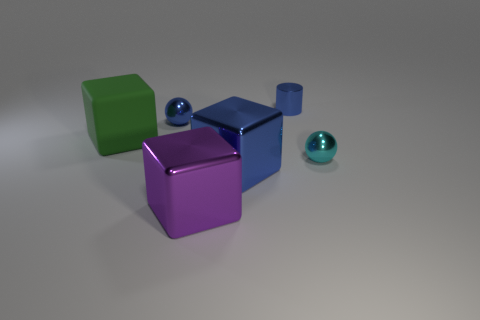There is a big cube behind the sphere in front of the big green cube; what is it made of?
Give a very brief answer. Rubber. Is there a large green thing of the same shape as the cyan shiny thing?
Make the answer very short. No. How many other things are there of the same shape as the big purple metal thing?
Give a very brief answer. 2. There is a metal thing that is in front of the small blue metallic ball and to the left of the big blue shiny object; what shape is it?
Offer a very short reply. Cube. What size is the metallic sphere that is behind the small cyan sphere?
Give a very brief answer. Small. Do the cyan metal thing and the purple thing have the same size?
Provide a short and direct response. No. Are there fewer blue cylinders that are to the left of the green rubber object than balls that are behind the tiny cylinder?
Your answer should be very brief. No. There is a thing that is behind the big blue cube and in front of the big green matte block; what is its size?
Provide a short and direct response. Small. There is a tiny blue shiny sphere that is on the left side of the tiny sphere right of the small blue cylinder; is there a big thing on the left side of it?
Provide a succinct answer. Yes. Is there a large green metal cube?
Keep it short and to the point. No. 